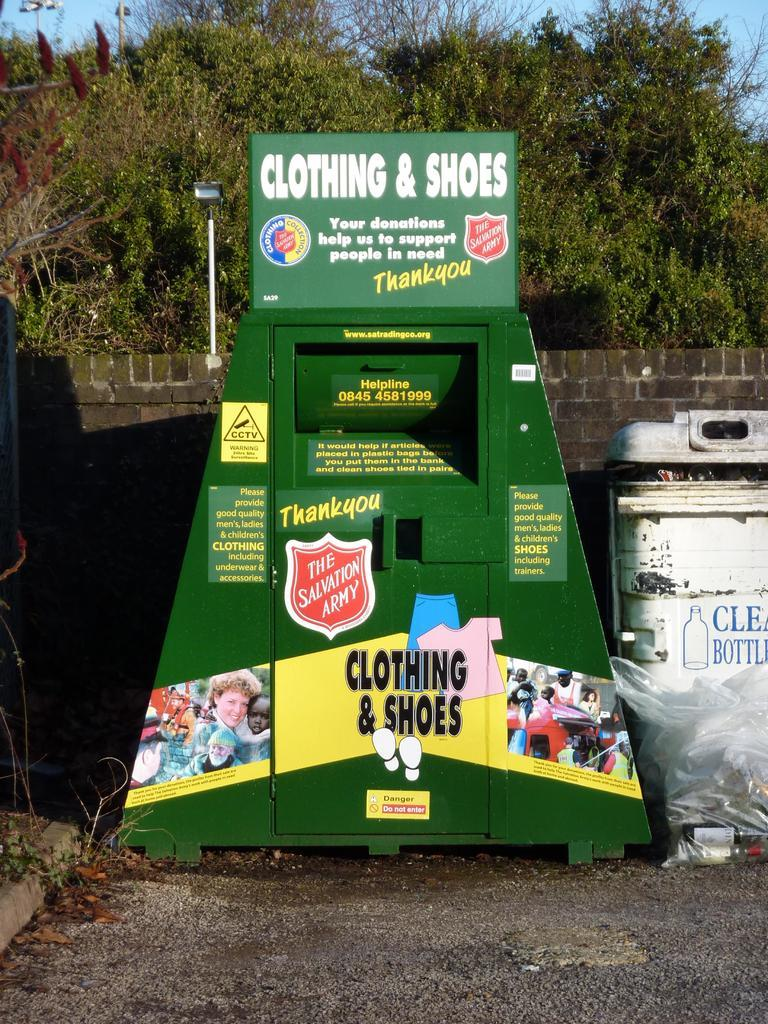Provide a one-sentence caption for the provided image. Clothing and shoes donation box from the salvation army. 